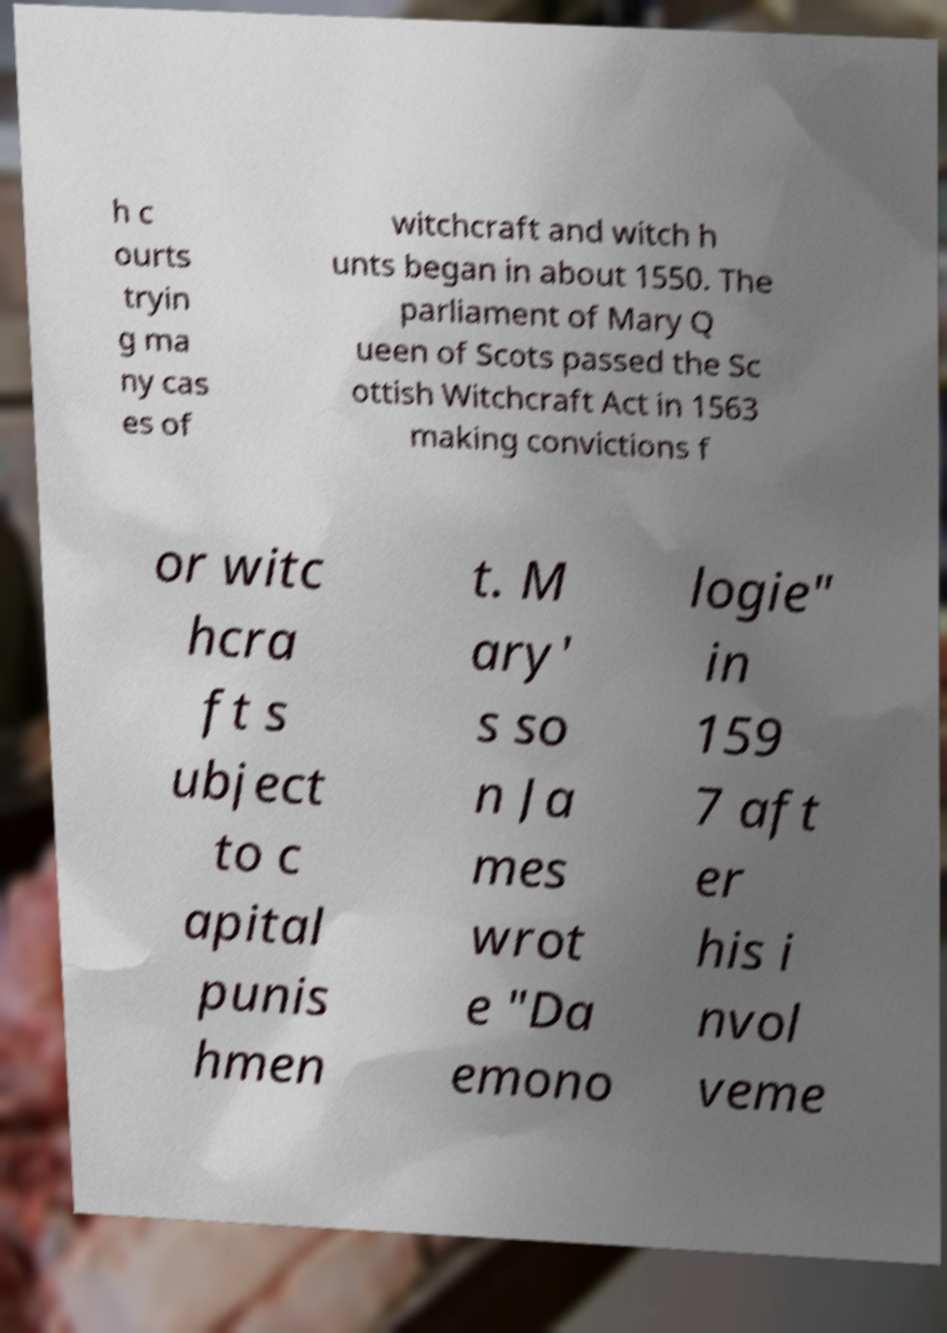What messages or text are displayed in this image? I need them in a readable, typed format. h c ourts tryin g ma ny cas es of witchcraft and witch h unts began in about 1550. The parliament of Mary Q ueen of Scots passed the Sc ottish Witchcraft Act in 1563 making convictions f or witc hcra ft s ubject to c apital punis hmen t. M ary' s so n Ja mes wrot e "Da emono logie" in 159 7 aft er his i nvol veme 